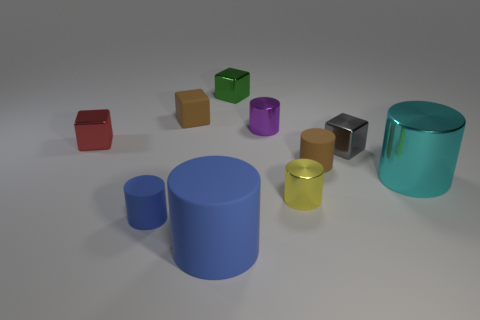Subtract all brown cylinders. How many cylinders are left? 5 Subtract all cyan metal cylinders. How many cylinders are left? 5 Subtract all gray cylinders. Subtract all purple balls. How many cylinders are left? 6 Subtract all cubes. How many objects are left? 6 Add 1 small blue things. How many small blue things exist? 2 Subtract 0 red spheres. How many objects are left? 10 Subtract all tiny gray metal spheres. Subtract all large cyan objects. How many objects are left? 9 Add 2 blue matte things. How many blue matte things are left? 4 